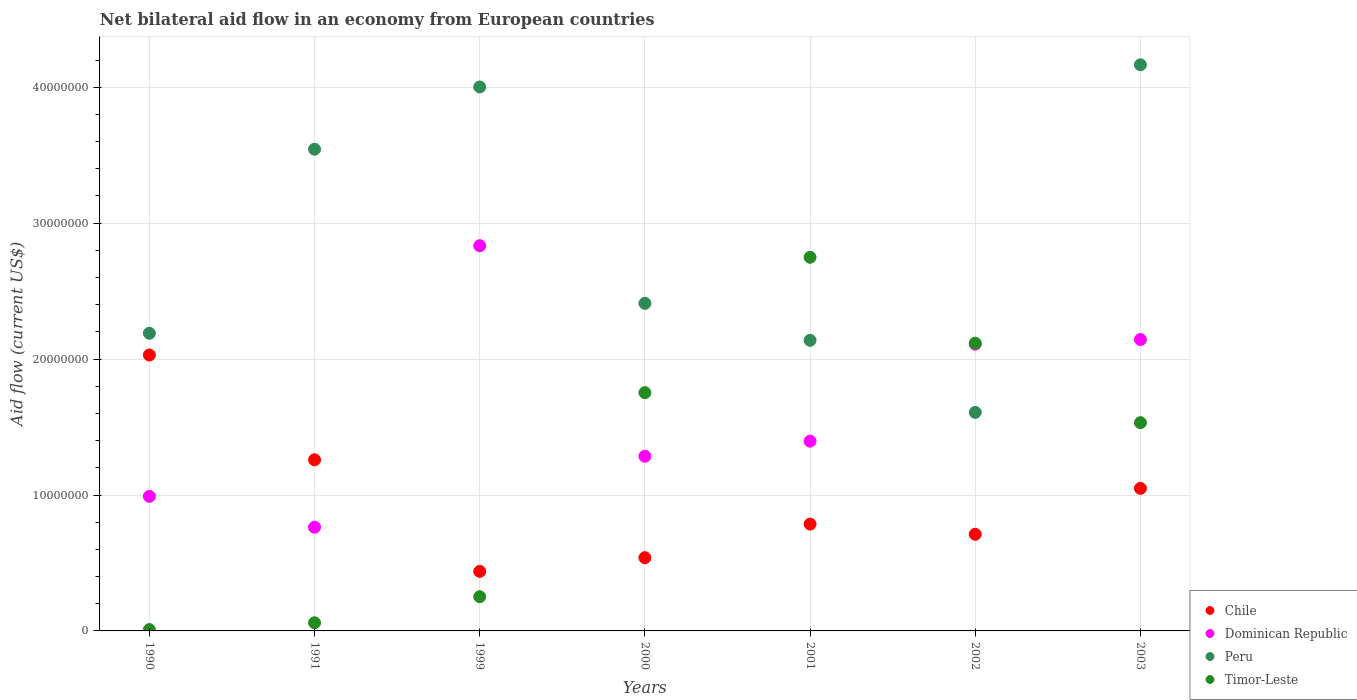Is the number of dotlines equal to the number of legend labels?
Offer a terse response. Yes. What is the net bilateral aid flow in Dominican Republic in 2003?
Offer a terse response. 2.14e+07. Across all years, what is the maximum net bilateral aid flow in Peru?
Provide a short and direct response. 4.16e+07. Across all years, what is the minimum net bilateral aid flow in Dominican Republic?
Give a very brief answer. 7.63e+06. In which year was the net bilateral aid flow in Dominican Republic maximum?
Offer a terse response. 1999. What is the total net bilateral aid flow in Peru in the graph?
Offer a terse response. 2.01e+08. What is the difference between the net bilateral aid flow in Chile in 2001 and that in 2003?
Keep it short and to the point. -2.63e+06. What is the difference between the net bilateral aid flow in Dominican Republic in 1991 and the net bilateral aid flow in Peru in 2000?
Provide a succinct answer. -1.65e+07. What is the average net bilateral aid flow in Chile per year?
Give a very brief answer. 9.73e+06. In the year 1999, what is the difference between the net bilateral aid flow in Dominican Republic and net bilateral aid flow in Chile?
Your answer should be very brief. 2.40e+07. What is the ratio of the net bilateral aid flow in Dominican Republic in 1991 to that in 2003?
Offer a terse response. 0.36. Is the net bilateral aid flow in Chile in 1999 less than that in 2000?
Your response must be concise. Yes. What is the difference between the highest and the second highest net bilateral aid flow in Timor-Leste?
Offer a terse response. 6.32e+06. What is the difference between the highest and the lowest net bilateral aid flow in Timor-Leste?
Offer a very short reply. 2.74e+07. In how many years, is the net bilateral aid flow in Chile greater than the average net bilateral aid flow in Chile taken over all years?
Make the answer very short. 3. Is it the case that in every year, the sum of the net bilateral aid flow in Peru and net bilateral aid flow in Chile  is greater than the sum of net bilateral aid flow in Timor-Leste and net bilateral aid flow in Dominican Republic?
Give a very brief answer. Yes. Is it the case that in every year, the sum of the net bilateral aid flow in Peru and net bilateral aid flow in Dominican Republic  is greater than the net bilateral aid flow in Timor-Leste?
Give a very brief answer. Yes. Does the net bilateral aid flow in Peru monotonically increase over the years?
Give a very brief answer. No. Does the graph contain any zero values?
Provide a short and direct response. No. Does the graph contain grids?
Your answer should be compact. Yes. How many legend labels are there?
Offer a terse response. 4. How are the legend labels stacked?
Your answer should be very brief. Vertical. What is the title of the graph?
Your answer should be very brief. Net bilateral aid flow in an economy from European countries. What is the Aid flow (current US$) in Chile in 1990?
Ensure brevity in your answer.  2.03e+07. What is the Aid flow (current US$) in Dominican Republic in 1990?
Make the answer very short. 9.90e+06. What is the Aid flow (current US$) in Peru in 1990?
Your response must be concise. 2.19e+07. What is the Aid flow (current US$) of Timor-Leste in 1990?
Ensure brevity in your answer.  1.00e+05. What is the Aid flow (current US$) of Chile in 1991?
Offer a very short reply. 1.26e+07. What is the Aid flow (current US$) in Dominican Republic in 1991?
Provide a short and direct response. 7.63e+06. What is the Aid flow (current US$) in Peru in 1991?
Your response must be concise. 3.54e+07. What is the Aid flow (current US$) in Chile in 1999?
Give a very brief answer. 4.38e+06. What is the Aid flow (current US$) of Dominican Republic in 1999?
Provide a succinct answer. 2.83e+07. What is the Aid flow (current US$) of Peru in 1999?
Your answer should be very brief. 4.00e+07. What is the Aid flow (current US$) in Timor-Leste in 1999?
Provide a succinct answer. 2.52e+06. What is the Aid flow (current US$) of Chile in 2000?
Offer a terse response. 5.39e+06. What is the Aid flow (current US$) in Dominican Republic in 2000?
Offer a terse response. 1.28e+07. What is the Aid flow (current US$) in Peru in 2000?
Offer a terse response. 2.41e+07. What is the Aid flow (current US$) in Timor-Leste in 2000?
Your answer should be very brief. 1.75e+07. What is the Aid flow (current US$) of Chile in 2001?
Make the answer very short. 7.86e+06. What is the Aid flow (current US$) in Dominican Republic in 2001?
Your response must be concise. 1.40e+07. What is the Aid flow (current US$) of Peru in 2001?
Your response must be concise. 2.14e+07. What is the Aid flow (current US$) in Timor-Leste in 2001?
Your response must be concise. 2.75e+07. What is the Aid flow (current US$) of Chile in 2002?
Give a very brief answer. 7.11e+06. What is the Aid flow (current US$) in Dominican Republic in 2002?
Provide a short and direct response. 2.11e+07. What is the Aid flow (current US$) in Peru in 2002?
Your answer should be very brief. 1.61e+07. What is the Aid flow (current US$) in Timor-Leste in 2002?
Provide a succinct answer. 2.12e+07. What is the Aid flow (current US$) of Chile in 2003?
Keep it short and to the point. 1.05e+07. What is the Aid flow (current US$) of Dominican Republic in 2003?
Provide a succinct answer. 2.14e+07. What is the Aid flow (current US$) of Peru in 2003?
Keep it short and to the point. 4.16e+07. What is the Aid flow (current US$) of Timor-Leste in 2003?
Provide a short and direct response. 1.53e+07. Across all years, what is the maximum Aid flow (current US$) in Chile?
Make the answer very short. 2.03e+07. Across all years, what is the maximum Aid flow (current US$) in Dominican Republic?
Make the answer very short. 2.83e+07. Across all years, what is the maximum Aid flow (current US$) of Peru?
Make the answer very short. 4.16e+07. Across all years, what is the maximum Aid flow (current US$) of Timor-Leste?
Keep it short and to the point. 2.75e+07. Across all years, what is the minimum Aid flow (current US$) in Chile?
Ensure brevity in your answer.  4.38e+06. Across all years, what is the minimum Aid flow (current US$) of Dominican Republic?
Provide a short and direct response. 7.63e+06. Across all years, what is the minimum Aid flow (current US$) of Peru?
Offer a terse response. 1.61e+07. What is the total Aid flow (current US$) of Chile in the graph?
Your response must be concise. 6.81e+07. What is the total Aid flow (current US$) of Dominican Republic in the graph?
Your response must be concise. 1.15e+08. What is the total Aid flow (current US$) of Peru in the graph?
Offer a very short reply. 2.01e+08. What is the total Aid flow (current US$) in Timor-Leste in the graph?
Keep it short and to the point. 8.47e+07. What is the difference between the Aid flow (current US$) of Chile in 1990 and that in 1991?
Make the answer very short. 7.71e+06. What is the difference between the Aid flow (current US$) in Dominican Republic in 1990 and that in 1991?
Give a very brief answer. 2.27e+06. What is the difference between the Aid flow (current US$) in Peru in 1990 and that in 1991?
Provide a succinct answer. -1.35e+07. What is the difference between the Aid flow (current US$) of Timor-Leste in 1990 and that in 1991?
Your response must be concise. -5.00e+05. What is the difference between the Aid flow (current US$) of Chile in 1990 and that in 1999?
Your answer should be compact. 1.59e+07. What is the difference between the Aid flow (current US$) in Dominican Republic in 1990 and that in 1999?
Ensure brevity in your answer.  -1.84e+07. What is the difference between the Aid flow (current US$) in Peru in 1990 and that in 1999?
Your response must be concise. -1.81e+07. What is the difference between the Aid flow (current US$) in Timor-Leste in 1990 and that in 1999?
Give a very brief answer. -2.42e+06. What is the difference between the Aid flow (current US$) of Chile in 1990 and that in 2000?
Give a very brief answer. 1.49e+07. What is the difference between the Aid flow (current US$) of Dominican Republic in 1990 and that in 2000?
Provide a succinct answer. -2.95e+06. What is the difference between the Aid flow (current US$) of Peru in 1990 and that in 2000?
Ensure brevity in your answer.  -2.20e+06. What is the difference between the Aid flow (current US$) in Timor-Leste in 1990 and that in 2000?
Your response must be concise. -1.74e+07. What is the difference between the Aid flow (current US$) of Chile in 1990 and that in 2001?
Make the answer very short. 1.24e+07. What is the difference between the Aid flow (current US$) in Dominican Republic in 1990 and that in 2001?
Provide a succinct answer. -4.06e+06. What is the difference between the Aid flow (current US$) of Peru in 1990 and that in 2001?
Your answer should be very brief. 5.20e+05. What is the difference between the Aid flow (current US$) in Timor-Leste in 1990 and that in 2001?
Make the answer very short. -2.74e+07. What is the difference between the Aid flow (current US$) in Chile in 1990 and that in 2002?
Provide a succinct answer. 1.32e+07. What is the difference between the Aid flow (current US$) in Dominican Republic in 1990 and that in 2002?
Ensure brevity in your answer.  -1.12e+07. What is the difference between the Aid flow (current US$) in Peru in 1990 and that in 2002?
Provide a succinct answer. 5.82e+06. What is the difference between the Aid flow (current US$) in Timor-Leste in 1990 and that in 2002?
Ensure brevity in your answer.  -2.11e+07. What is the difference between the Aid flow (current US$) in Chile in 1990 and that in 2003?
Ensure brevity in your answer.  9.81e+06. What is the difference between the Aid flow (current US$) in Dominican Republic in 1990 and that in 2003?
Provide a succinct answer. -1.15e+07. What is the difference between the Aid flow (current US$) of Peru in 1990 and that in 2003?
Your response must be concise. -1.98e+07. What is the difference between the Aid flow (current US$) of Timor-Leste in 1990 and that in 2003?
Ensure brevity in your answer.  -1.52e+07. What is the difference between the Aid flow (current US$) in Chile in 1991 and that in 1999?
Keep it short and to the point. 8.21e+06. What is the difference between the Aid flow (current US$) in Dominican Republic in 1991 and that in 1999?
Keep it short and to the point. -2.07e+07. What is the difference between the Aid flow (current US$) in Peru in 1991 and that in 1999?
Your response must be concise. -4.58e+06. What is the difference between the Aid flow (current US$) in Timor-Leste in 1991 and that in 1999?
Your answer should be very brief. -1.92e+06. What is the difference between the Aid flow (current US$) of Chile in 1991 and that in 2000?
Provide a succinct answer. 7.20e+06. What is the difference between the Aid flow (current US$) of Dominican Republic in 1991 and that in 2000?
Give a very brief answer. -5.22e+06. What is the difference between the Aid flow (current US$) of Peru in 1991 and that in 2000?
Offer a very short reply. 1.13e+07. What is the difference between the Aid flow (current US$) of Timor-Leste in 1991 and that in 2000?
Provide a succinct answer. -1.69e+07. What is the difference between the Aid flow (current US$) of Chile in 1991 and that in 2001?
Provide a short and direct response. 4.73e+06. What is the difference between the Aid flow (current US$) in Dominican Republic in 1991 and that in 2001?
Provide a short and direct response. -6.33e+06. What is the difference between the Aid flow (current US$) in Peru in 1991 and that in 2001?
Your response must be concise. 1.41e+07. What is the difference between the Aid flow (current US$) in Timor-Leste in 1991 and that in 2001?
Your answer should be very brief. -2.69e+07. What is the difference between the Aid flow (current US$) in Chile in 1991 and that in 2002?
Keep it short and to the point. 5.48e+06. What is the difference between the Aid flow (current US$) in Dominican Republic in 1991 and that in 2002?
Give a very brief answer. -1.35e+07. What is the difference between the Aid flow (current US$) of Peru in 1991 and that in 2002?
Ensure brevity in your answer.  1.94e+07. What is the difference between the Aid flow (current US$) of Timor-Leste in 1991 and that in 2002?
Your answer should be compact. -2.06e+07. What is the difference between the Aid flow (current US$) in Chile in 1991 and that in 2003?
Keep it short and to the point. 2.10e+06. What is the difference between the Aid flow (current US$) of Dominican Republic in 1991 and that in 2003?
Your response must be concise. -1.38e+07. What is the difference between the Aid flow (current US$) in Peru in 1991 and that in 2003?
Your answer should be very brief. -6.21e+06. What is the difference between the Aid flow (current US$) of Timor-Leste in 1991 and that in 2003?
Provide a succinct answer. -1.47e+07. What is the difference between the Aid flow (current US$) of Chile in 1999 and that in 2000?
Your response must be concise. -1.01e+06. What is the difference between the Aid flow (current US$) in Dominican Republic in 1999 and that in 2000?
Provide a succinct answer. 1.55e+07. What is the difference between the Aid flow (current US$) of Peru in 1999 and that in 2000?
Your answer should be compact. 1.59e+07. What is the difference between the Aid flow (current US$) in Timor-Leste in 1999 and that in 2000?
Give a very brief answer. -1.50e+07. What is the difference between the Aid flow (current US$) of Chile in 1999 and that in 2001?
Make the answer very short. -3.48e+06. What is the difference between the Aid flow (current US$) of Dominican Republic in 1999 and that in 2001?
Offer a very short reply. 1.44e+07. What is the difference between the Aid flow (current US$) of Peru in 1999 and that in 2001?
Your answer should be very brief. 1.86e+07. What is the difference between the Aid flow (current US$) in Timor-Leste in 1999 and that in 2001?
Give a very brief answer. -2.50e+07. What is the difference between the Aid flow (current US$) of Chile in 1999 and that in 2002?
Keep it short and to the point. -2.73e+06. What is the difference between the Aid flow (current US$) in Dominican Republic in 1999 and that in 2002?
Offer a terse response. 7.24e+06. What is the difference between the Aid flow (current US$) of Peru in 1999 and that in 2002?
Ensure brevity in your answer.  2.39e+07. What is the difference between the Aid flow (current US$) in Timor-Leste in 1999 and that in 2002?
Your answer should be compact. -1.86e+07. What is the difference between the Aid flow (current US$) of Chile in 1999 and that in 2003?
Provide a succinct answer. -6.11e+06. What is the difference between the Aid flow (current US$) in Dominican Republic in 1999 and that in 2003?
Ensure brevity in your answer.  6.90e+06. What is the difference between the Aid flow (current US$) in Peru in 1999 and that in 2003?
Provide a short and direct response. -1.63e+06. What is the difference between the Aid flow (current US$) in Timor-Leste in 1999 and that in 2003?
Your answer should be very brief. -1.28e+07. What is the difference between the Aid flow (current US$) in Chile in 2000 and that in 2001?
Make the answer very short. -2.47e+06. What is the difference between the Aid flow (current US$) of Dominican Republic in 2000 and that in 2001?
Keep it short and to the point. -1.11e+06. What is the difference between the Aid flow (current US$) of Peru in 2000 and that in 2001?
Provide a short and direct response. 2.72e+06. What is the difference between the Aid flow (current US$) of Timor-Leste in 2000 and that in 2001?
Your answer should be very brief. -9.96e+06. What is the difference between the Aid flow (current US$) in Chile in 2000 and that in 2002?
Offer a terse response. -1.72e+06. What is the difference between the Aid flow (current US$) of Dominican Republic in 2000 and that in 2002?
Give a very brief answer. -8.25e+06. What is the difference between the Aid flow (current US$) in Peru in 2000 and that in 2002?
Offer a terse response. 8.02e+06. What is the difference between the Aid flow (current US$) of Timor-Leste in 2000 and that in 2002?
Your response must be concise. -3.64e+06. What is the difference between the Aid flow (current US$) of Chile in 2000 and that in 2003?
Your answer should be very brief. -5.10e+06. What is the difference between the Aid flow (current US$) in Dominican Republic in 2000 and that in 2003?
Provide a short and direct response. -8.59e+06. What is the difference between the Aid flow (current US$) in Peru in 2000 and that in 2003?
Provide a succinct answer. -1.76e+07. What is the difference between the Aid flow (current US$) of Timor-Leste in 2000 and that in 2003?
Ensure brevity in your answer.  2.21e+06. What is the difference between the Aid flow (current US$) of Chile in 2001 and that in 2002?
Ensure brevity in your answer.  7.50e+05. What is the difference between the Aid flow (current US$) of Dominican Republic in 2001 and that in 2002?
Keep it short and to the point. -7.14e+06. What is the difference between the Aid flow (current US$) of Peru in 2001 and that in 2002?
Ensure brevity in your answer.  5.30e+06. What is the difference between the Aid flow (current US$) in Timor-Leste in 2001 and that in 2002?
Make the answer very short. 6.32e+06. What is the difference between the Aid flow (current US$) of Chile in 2001 and that in 2003?
Your answer should be very brief. -2.63e+06. What is the difference between the Aid flow (current US$) in Dominican Republic in 2001 and that in 2003?
Offer a terse response. -7.48e+06. What is the difference between the Aid flow (current US$) in Peru in 2001 and that in 2003?
Ensure brevity in your answer.  -2.03e+07. What is the difference between the Aid flow (current US$) in Timor-Leste in 2001 and that in 2003?
Provide a short and direct response. 1.22e+07. What is the difference between the Aid flow (current US$) in Chile in 2002 and that in 2003?
Offer a terse response. -3.38e+06. What is the difference between the Aid flow (current US$) in Dominican Republic in 2002 and that in 2003?
Provide a short and direct response. -3.40e+05. What is the difference between the Aid flow (current US$) of Peru in 2002 and that in 2003?
Your answer should be compact. -2.56e+07. What is the difference between the Aid flow (current US$) of Timor-Leste in 2002 and that in 2003?
Give a very brief answer. 5.85e+06. What is the difference between the Aid flow (current US$) of Chile in 1990 and the Aid flow (current US$) of Dominican Republic in 1991?
Keep it short and to the point. 1.27e+07. What is the difference between the Aid flow (current US$) of Chile in 1990 and the Aid flow (current US$) of Peru in 1991?
Offer a terse response. -1.51e+07. What is the difference between the Aid flow (current US$) of Chile in 1990 and the Aid flow (current US$) of Timor-Leste in 1991?
Keep it short and to the point. 1.97e+07. What is the difference between the Aid flow (current US$) in Dominican Republic in 1990 and the Aid flow (current US$) in Peru in 1991?
Provide a short and direct response. -2.55e+07. What is the difference between the Aid flow (current US$) of Dominican Republic in 1990 and the Aid flow (current US$) of Timor-Leste in 1991?
Your answer should be very brief. 9.30e+06. What is the difference between the Aid flow (current US$) in Peru in 1990 and the Aid flow (current US$) in Timor-Leste in 1991?
Provide a succinct answer. 2.13e+07. What is the difference between the Aid flow (current US$) in Chile in 1990 and the Aid flow (current US$) in Dominican Republic in 1999?
Offer a terse response. -8.04e+06. What is the difference between the Aid flow (current US$) in Chile in 1990 and the Aid flow (current US$) in Peru in 1999?
Provide a succinct answer. -1.97e+07. What is the difference between the Aid flow (current US$) of Chile in 1990 and the Aid flow (current US$) of Timor-Leste in 1999?
Your answer should be very brief. 1.78e+07. What is the difference between the Aid flow (current US$) in Dominican Republic in 1990 and the Aid flow (current US$) in Peru in 1999?
Offer a very short reply. -3.01e+07. What is the difference between the Aid flow (current US$) of Dominican Republic in 1990 and the Aid flow (current US$) of Timor-Leste in 1999?
Provide a succinct answer. 7.38e+06. What is the difference between the Aid flow (current US$) in Peru in 1990 and the Aid flow (current US$) in Timor-Leste in 1999?
Offer a very short reply. 1.94e+07. What is the difference between the Aid flow (current US$) in Chile in 1990 and the Aid flow (current US$) in Dominican Republic in 2000?
Give a very brief answer. 7.45e+06. What is the difference between the Aid flow (current US$) in Chile in 1990 and the Aid flow (current US$) in Peru in 2000?
Keep it short and to the point. -3.80e+06. What is the difference between the Aid flow (current US$) of Chile in 1990 and the Aid flow (current US$) of Timor-Leste in 2000?
Your answer should be very brief. 2.77e+06. What is the difference between the Aid flow (current US$) in Dominican Republic in 1990 and the Aid flow (current US$) in Peru in 2000?
Provide a short and direct response. -1.42e+07. What is the difference between the Aid flow (current US$) in Dominican Republic in 1990 and the Aid flow (current US$) in Timor-Leste in 2000?
Your answer should be very brief. -7.63e+06. What is the difference between the Aid flow (current US$) of Peru in 1990 and the Aid flow (current US$) of Timor-Leste in 2000?
Your answer should be compact. 4.37e+06. What is the difference between the Aid flow (current US$) of Chile in 1990 and the Aid flow (current US$) of Dominican Republic in 2001?
Make the answer very short. 6.34e+06. What is the difference between the Aid flow (current US$) in Chile in 1990 and the Aid flow (current US$) in Peru in 2001?
Offer a terse response. -1.08e+06. What is the difference between the Aid flow (current US$) of Chile in 1990 and the Aid flow (current US$) of Timor-Leste in 2001?
Your response must be concise. -7.19e+06. What is the difference between the Aid flow (current US$) of Dominican Republic in 1990 and the Aid flow (current US$) of Peru in 2001?
Give a very brief answer. -1.15e+07. What is the difference between the Aid flow (current US$) of Dominican Republic in 1990 and the Aid flow (current US$) of Timor-Leste in 2001?
Keep it short and to the point. -1.76e+07. What is the difference between the Aid flow (current US$) in Peru in 1990 and the Aid flow (current US$) in Timor-Leste in 2001?
Offer a very short reply. -5.59e+06. What is the difference between the Aid flow (current US$) of Chile in 1990 and the Aid flow (current US$) of Dominican Republic in 2002?
Your answer should be very brief. -8.00e+05. What is the difference between the Aid flow (current US$) of Chile in 1990 and the Aid flow (current US$) of Peru in 2002?
Make the answer very short. 4.22e+06. What is the difference between the Aid flow (current US$) of Chile in 1990 and the Aid flow (current US$) of Timor-Leste in 2002?
Offer a terse response. -8.70e+05. What is the difference between the Aid flow (current US$) of Dominican Republic in 1990 and the Aid flow (current US$) of Peru in 2002?
Give a very brief answer. -6.18e+06. What is the difference between the Aid flow (current US$) of Dominican Republic in 1990 and the Aid flow (current US$) of Timor-Leste in 2002?
Your answer should be very brief. -1.13e+07. What is the difference between the Aid flow (current US$) in Peru in 1990 and the Aid flow (current US$) in Timor-Leste in 2002?
Offer a very short reply. 7.30e+05. What is the difference between the Aid flow (current US$) in Chile in 1990 and the Aid flow (current US$) in Dominican Republic in 2003?
Provide a succinct answer. -1.14e+06. What is the difference between the Aid flow (current US$) in Chile in 1990 and the Aid flow (current US$) in Peru in 2003?
Provide a short and direct response. -2.14e+07. What is the difference between the Aid flow (current US$) of Chile in 1990 and the Aid flow (current US$) of Timor-Leste in 2003?
Offer a terse response. 4.98e+06. What is the difference between the Aid flow (current US$) in Dominican Republic in 1990 and the Aid flow (current US$) in Peru in 2003?
Your answer should be compact. -3.18e+07. What is the difference between the Aid flow (current US$) in Dominican Republic in 1990 and the Aid flow (current US$) in Timor-Leste in 2003?
Your answer should be very brief. -5.42e+06. What is the difference between the Aid flow (current US$) of Peru in 1990 and the Aid flow (current US$) of Timor-Leste in 2003?
Your answer should be compact. 6.58e+06. What is the difference between the Aid flow (current US$) in Chile in 1991 and the Aid flow (current US$) in Dominican Republic in 1999?
Keep it short and to the point. -1.58e+07. What is the difference between the Aid flow (current US$) in Chile in 1991 and the Aid flow (current US$) in Peru in 1999?
Your answer should be compact. -2.74e+07. What is the difference between the Aid flow (current US$) in Chile in 1991 and the Aid flow (current US$) in Timor-Leste in 1999?
Your answer should be compact. 1.01e+07. What is the difference between the Aid flow (current US$) in Dominican Republic in 1991 and the Aid flow (current US$) in Peru in 1999?
Offer a terse response. -3.24e+07. What is the difference between the Aid flow (current US$) in Dominican Republic in 1991 and the Aid flow (current US$) in Timor-Leste in 1999?
Ensure brevity in your answer.  5.11e+06. What is the difference between the Aid flow (current US$) in Peru in 1991 and the Aid flow (current US$) in Timor-Leste in 1999?
Provide a succinct answer. 3.29e+07. What is the difference between the Aid flow (current US$) of Chile in 1991 and the Aid flow (current US$) of Dominican Republic in 2000?
Provide a short and direct response. -2.60e+05. What is the difference between the Aid flow (current US$) of Chile in 1991 and the Aid flow (current US$) of Peru in 2000?
Your answer should be compact. -1.15e+07. What is the difference between the Aid flow (current US$) in Chile in 1991 and the Aid flow (current US$) in Timor-Leste in 2000?
Offer a terse response. -4.94e+06. What is the difference between the Aid flow (current US$) of Dominican Republic in 1991 and the Aid flow (current US$) of Peru in 2000?
Provide a succinct answer. -1.65e+07. What is the difference between the Aid flow (current US$) in Dominican Republic in 1991 and the Aid flow (current US$) in Timor-Leste in 2000?
Your answer should be compact. -9.90e+06. What is the difference between the Aid flow (current US$) in Peru in 1991 and the Aid flow (current US$) in Timor-Leste in 2000?
Your answer should be compact. 1.79e+07. What is the difference between the Aid flow (current US$) of Chile in 1991 and the Aid flow (current US$) of Dominican Republic in 2001?
Provide a short and direct response. -1.37e+06. What is the difference between the Aid flow (current US$) in Chile in 1991 and the Aid flow (current US$) in Peru in 2001?
Offer a very short reply. -8.79e+06. What is the difference between the Aid flow (current US$) of Chile in 1991 and the Aid flow (current US$) of Timor-Leste in 2001?
Your answer should be very brief. -1.49e+07. What is the difference between the Aid flow (current US$) in Dominican Republic in 1991 and the Aid flow (current US$) in Peru in 2001?
Give a very brief answer. -1.38e+07. What is the difference between the Aid flow (current US$) in Dominican Republic in 1991 and the Aid flow (current US$) in Timor-Leste in 2001?
Offer a terse response. -1.99e+07. What is the difference between the Aid flow (current US$) in Peru in 1991 and the Aid flow (current US$) in Timor-Leste in 2001?
Make the answer very short. 7.95e+06. What is the difference between the Aid flow (current US$) of Chile in 1991 and the Aid flow (current US$) of Dominican Republic in 2002?
Provide a short and direct response. -8.51e+06. What is the difference between the Aid flow (current US$) in Chile in 1991 and the Aid flow (current US$) in Peru in 2002?
Ensure brevity in your answer.  -3.49e+06. What is the difference between the Aid flow (current US$) of Chile in 1991 and the Aid flow (current US$) of Timor-Leste in 2002?
Provide a short and direct response. -8.58e+06. What is the difference between the Aid flow (current US$) of Dominican Republic in 1991 and the Aid flow (current US$) of Peru in 2002?
Your response must be concise. -8.45e+06. What is the difference between the Aid flow (current US$) of Dominican Republic in 1991 and the Aid flow (current US$) of Timor-Leste in 2002?
Offer a terse response. -1.35e+07. What is the difference between the Aid flow (current US$) in Peru in 1991 and the Aid flow (current US$) in Timor-Leste in 2002?
Provide a succinct answer. 1.43e+07. What is the difference between the Aid flow (current US$) in Chile in 1991 and the Aid flow (current US$) in Dominican Republic in 2003?
Provide a succinct answer. -8.85e+06. What is the difference between the Aid flow (current US$) of Chile in 1991 and the Aid flow (current US$) of Peru in 2003?
Offer a terse response. -2.91e+07. What is the difference between the Aid flow (current US$) of Chile in 1991 and the Aid flow (current US$) of Timor-Leste in 2003?
Keep it short and to the point. -2.73e+06. What is the difference between the Aid flow (current US$) in Dominican Republic in 1991 and the Aid flow (current US$) in Peru in 2003?
Offer a very short reply. -3.40e+07. What is the difference between the Aid flow (current US$) in Dominican Republic in 1991 and the Aid flow (current US$) in Timor-Leste in 2003?
Keep it short and to the point. -7.69e+06. What is the difference between the Aid flow (current US$) of Peru in 1991 and the Aid flow (current US$) of Timor-Leste in 2003?
Ensure brevity in your answer.  2.01e+07. What is the difference between the Aid flow (current US$) in Chile in 1999 and the Aid flow (current US$) in Dominican Republic in 2000?
Give a very brief answer. -8.47e+06. What is the difference between the Aid flow (current US$) of Chile in 1999 and the Aid flow (current US$) of Peru in 2000?
Your answer should be very brief. -1.97e+07. What is the difference between the Aid flow (current US$) of Chile in 1999 and the Aid flow (current US$) of Timor-Leste in 2000?
Make the answer very short. -1.32e+07. What is the difference between the Aid flow (current US$) of Dominican Republic in 1999 and the Aid flow (current US$) of Peru in 2000?
Give a very brief answer. 4.24e+06. What is the difference between the Aid flow (current US$) of Dominican Republic in 1999 and the Aid flow (current US$) of Timor-Leste in 2000?
Your response must be concise. 1.08e+07. What is the difference between the Aid flow (current US$) in Peru in 1999 and the Aid flow (current US$) in Timor-Leste in 2000?
Give a very brief answer. 2.25e+07. What is the difference between the Aid flow (current US$) of Chile in 1999 and the Aid flow (current US$) of Dominican Republic in 2001?
Offer a terse response. -9.58e+06. What is the difference between the Aid flow (current US$) of Chile in 1999 and the Aid flow (current US$) of Peru in 2001?
Provide a short and direct response. -1.70e+07. What is the difference between the Aid flow (current US$) of Chile in 1999 and the Aid flow (current US$) of Timor-Leste in 2001?
Offer a terse response. -2.31e+07. What is the difference between the Aid flow (current US$) in Dominican Republic in 1999 and the Aid flow (current US$) in Peru in 2001?
Ensure brevity in your answer.  6.96e+06. What is the difference between the Aid flow (current US$) in Dominican Republic in 1999 and the Aid flow (current US$) in Timor-Leste in 2001?
Offer a very short reply. 8.50e+05. What is the difference between the Aid flow (current US$) of Peru in 1999 and the Aid flow (current US$) of Timor-Leste in 2001?
Your answer should be compact. 1.25e+07. What is the difference between the Aid flow (current US$) in Chile in 1999 and the Aid flow (current US$) in Dominican Republic in 2002?
Ensure brevity in your answer.  -1.67e+07. What is the difference between the Aid flow (current US$) of Chile in 1999 and the Aid flow (current US$) of Peru in 2002?
Your answer should be very brief. -1.17e+07. What is the difference between the Aid flow (current US$) of Chile in 1999 and the Aid flow (current US$) of Timor-Leste in 2002?
Keep it short and to the point. -1.68e+07. What is the difference between the Aid flow (current US$) of Dominican Republic in 1999 and the Aid flow (current US$) of Peru in 2002?
Offer a very short reply. 1.23e+07. What is the difference between the Aid flow (current US$) in Dominican Republic in 1999 and the Aid flow (current US$) in Timor-Leste in 2002?
Give a very brief answer. 7.17e+06. What is the difference between the Aid flow (current US$) in Peru in 1999 and the Aid flow (current US$) in Timor-Leste in 2002?
Give a very brief answer. 1.88e+07. What is the difference between the Aid flow (current US$) of Chile in 1999 and the Aid flow (current US$) of Dominican Republic in 2003?
Your answer should be very brief. -1.71e+07. What is the difference between the Aid flow (current US$) of Chile in 1999 and the Aid flow (current US$) of Peru in 2003?
Provide a short and direct response. -3.73e+07. What is the difference between the Aid flow (current US$) of Chile in 1999 and the Aid flow (current US$) of Timor-Leste in 2003?
Your response must be concise. -1.09e+07. What is the difference between the Aid flow (current US$) of Dominican Republic in 1999 and the Aid flow (current US$) of Peru in 2003?
Provide a short and direct response. -1.33e+07. What is the difference between the Aid flow (current US$) in Dominican Republic in 1999 and the Aid flow (current US$) in Timor-Leste in 2003?
Make the answer very short. 1.30e+07. What is the difference between the Aid flow (current US$) in Peru in 1999 and the Aid flow (current US$) in Timor-Leste in 2003?
Give a very brief answer. 2.47e+07. What is the difference between the Aid flow (current US$) in Chile in 2000 and the Aid flow (current US$) in Dominican Republic in 2001?
Give a very brief answer. -8.57e+06. What is the difference between the Aid flow (current US$) of Chile in 2000 and the Aid flow (current US$) of Peru in 2001?
Offer a terse response. -1.60e+07. What is the difference between the Aid flow (current US$) of Chile in 2000 and the Aid flow (current US$) of Timor-Leste in 2001?
Ensure brevity in your answer.  -2.21e+07. What is the difference between the Aid flow (current US$) of Dominican Republic in 2000 and the Aid flow (current US$) of Peru in 2001?
Make the answer very short. -8.53e+06. What is the difference between the Aid flow (current US$) in Dominican Republic in 2000 and the Aid flow (current US$) in Timor-Leste in 2001?
Offer a terse response. -1.46e+07. What is the difference between the Aid flow (current US$) of Peru in 2000 and the Aid flow (current US$) of Timor-Leste in 2001?
Provide a succinct answer. -3.39e+06. What is the difference between the Aid flow (current US$) of Chile in 2000 and the Aid flow (current US$) of Dominican Republic in 2002?
Keep it short and to the point. -1.57e+07. What is the difference between the Aid flow (current US$) in Chile in 2000 and the Aid flow (current US$) in Peru in 2002?
Make the answer very short. -1.07e+07. What is the difference between the Aid flow (current US$) in Chile in 2000 and the Aid flow (current US$) in Timor-Leste in 2002?
Offer a very short reply. -1.58e+07. What is the difference between the Aid flow (current US$) in Dominican Republic in 2000 and the Aid flow (current US$) in Peru in 2002?
Make the answer very short. -3.23e+06. What is the difference between the Aid flow (current US$) of Dominican Republic in 2000 and the Aid flow (current US$) of Timor-Leste in 2002?
Provide a short and direct response. -8.32e+06. What is the difference between the Aid flow (current US$) in Peru in 2000 and the Aid flow (current US$) in Timor-Leste in 2002?
Give a very brief answer. 2.93e+06. What is the difference between the Aid flow (current US$) of Chile in 2000 and the Aid flow (current US$) of Dominican Republic in 2003?
Your response must be concise. -1.60e+07. What is the difference between the Aid flow (current US$) in Chile in 2000 and the Aid flow (current US$) in Peru in 2003?
Offer a very short reply. -3.63e+07. What is the difference between the Aid flow (current US$) in Chile in 2000 and the Aid flow (current US$) in Timor-Leste in 2003?
Give a very brief answer. -9.93e+06. What is the difference between the Aid flow (current US$) in Dominican Republic in 2000 and the Aid flow (current US$) in Peru in 2003?
Your answer should be compact. -2.88e+07. What is the difference between the Aid flow (current US$) in Dominican Republic in 2000 and the Aid flow (current US$) in Timor-Leste in 2003?
Your answer should be compact. -2.47e+06. What is the difference between the Aid flow (current US$) of Peru in 2000 and the Aid flow (current US$) of Timor-Leste in 2003?
Provide a short and direct response. 8.78e+06. What is the difference between the Aid flow (current US$) of Chile in 2001 and the Aid flow (current US$) of Dominican Republic in 2002?
Offer a terse response. -1.32e+07. What is the difference between the Aid flow (current US$) of Chile in 2001 and the Aid flow (current US$) of Peru in 2002?
Make the answer very short. -8.22e+06. What is the difference between the Aid flow (current US$) of Chile in 2001 and the Aid flow (current US$) of Timor-Leste in 2002?
Your answer should be very brief. -1.33e+07. What is the difference between the Aid flow (current US$) in Dominican Republic in 2001 and the Aid flow (current US$) in Peru in 2002?
Your answer should be very brief. -2.12e+06. What is the difference between the Aid flow (current US$) of Dominican Republic in 2001 and the Aid flow (current US$) of Timor-Leste in 2002?
Provide a succinct answer. -7.21e+06. What is the difference between the Aid flow (current US$) in Peru in 2001 and the Aid flow (current US$) in Timor-Leste in 2002?
Your response must be concise. 2.10e+05. What is the difference between the Aid flow (current US$) of Chile in 2001 and the Aid flow (current US$) of Dominican Republic in 2003?
Make the answer very short. -1.36e+07. What is the difference between the Aid flow (current US$) of Chile in 2001 and the Aid flow (current US$) of Peru in 2003?
Your answer should be compact. -3.38e+07. What is the difference between the Aid flow (current US$) in Chile in 2001 and the Aid flow (current US$) in Timor-Leste in 2003?
Your answer should be very brief. -7.46e+06. What is the difference between the Aid flow (current US$) of Dominican Republic in 2001 and the Aid flow (current US$) of Peru in 2003?
Keep it short and to the point. -2.77e+07. What is the difference between the Aid flow (current US$) in Dominican Republic in 2001 and the Aid flow (current US$) in Timor-Leste in 2003?
Your response must be concise. -1.36e+06. What is the difference between the Aid flow (current US$) in Peru in 2001 and the Aid flow (current US$) in Timor-Leste in 2003?
Your response must be concise. 6.06e+06. What is the difference between the Aid flow (current US$) of Chile in 2002 and the Aid flow (current US$) of Dominican Republic in 2003?
Your response must be concise. -1.43e+07. What is the difference between the Aid flow (current US$) in Chile in 2002 and the Aid flow (current US$) in Peru in 2003?
Keep it short and to the point. -3.45e+07. What is the difference between the Aid flow (current US$) in Chile in 2002 and the Aid flow (current US$) in Timor-Leste in 2003?
Give a very brief answer. -8.21e+06. What is the difference between the Aid flow (current US$) in Dominican Republic in 2002 and the Aid flow (current US$) in Peru in 2003?
Your answer should be very brief. -2.06e+07. What is the difference between the Aid flow (current US$) of Dominican Republic in 2002 and the Aid flow (current US$) of Timor-Leste in 2003?
Offer a terse response. 5.78e+06. What is the difference between the Aid flow (current US$) in Peru in 2002 and the Aid flow (current US$) in Timor-Leste in 2003?
Your response must be concise. 7.60e+05. What is the average Aid flow (current US$) in Chile per year?
Your answer should be very brief. 9.73e+06. What is the average Aid flow (current US$) of Dominican Republic per year?
Offer a very short reply. 1.65e+07. What is the average Aid flow (current US$) in Peru per year?
Offer a terse response. 2.87e+07. What is the average Aid flow (current US$) of Timor-Leste per year?
Keep it short and to the point. 1.21e+07. In the year 1990, what is the difference between the Aid flow (current US$) of Chile and Aid flow (current US$) of Dominican Republic?
Make the answer very short. 1.04e+07. In the year 1990, what is the difference between the Aid flow (current US$) of Chile and Aid flow (current US$) of Peru?
Provide a short and direct response. -1.60e+06. In the year 1990, what is the difference between the Aid flow (current US$) in Chile and Aid flow (current US$) in Timor-Leste?
Offer a very short reply. 2.02e+07. In the year 1990, what is the difference between the Aid flow (current US$) in Dominican Republic and Aid flow (current US$) in Peru?
Make the answer very short. -1.20e+07. In the year 1990, what is the difference between the Aid flow (current US$) of Dominican Republic and Aid flow (current US$) of Timor-Leste?
Your response must be concise. 9.80e+06. In the year 1990, what is the difference between the Aid flow (current US$) in Peru and Aid flow (current US$) in Timor-Leste?
Offer a very short reply. 2.18e+07. In the year 1991, what is the difference between the Aid flow (current US$) in Chile and Aid flow (current US$) in Dominican Republic?
Keep it short and to the point. 4.96e+06. In the year 1991, what is the difference between the Aid flow (current US$) in Chile and Aid flow (current US$) in Peru?
Offer a very short reply. -2.28e+07. In the year 1991, what is the difference between the Aid flow (current US$) in Chile and Aid flow (current US$) in Timor-Leste?
Make the answer very short. 1.20e+07. In the year 1991, what is the difference between the Aid flow (current US$) of Dominican Republic and Aid flow (current US$) of Peru?
Your response must be concise. -2.78e+07. In the year 1991, what is the difference between the Aid flow (current US$) in Dominican Republic and Aid flow (current US$) in Timor-Leste?
Ensure brevity in your answer.  7.03e+06. In the year 1991, what is the difference between the Aid flow (current US$) of Peru and Aid flow (current US$) of Timor-Leste?
Your answer should be compact. 3.48e+07. In the year 1999, what is the difference between the Aid flow (current US$) of Chile and Aid flow (current US$) of Dominican Republic?
Provide a succinct answer. -2.40e+07. In the year 1999, what is the difference between the Aid flow (current US$) of Chile and Aid flow (current US$) of Peru?
Offer a terse response. -3.56e+07. In the year 1999, what is the difference between the Aid flow (current US$) of Chile and Aid flow (current US$) of Timor-Leste?
Provide a succinct answer. 1.86e+06. In the year 1999, what is the difference between the Aid flow (current US$) in Dominican Republic and Aid flow (current US$) in Peru?
Your response must be concise. -1.17e+07. In the year 1999, what is the difference between the Aid flow (current US$) in Dominican Republic and Aid flow (current US$) in Timor-Leste?
Ensure brevity in your answer.  2.58e+07. In the year 1999, what is the difference between the Aid flow (current US$) of Peru and Aid flow (current US$) of Timor-Leste?
Make the answer very short. 3.75e+07. In the year 2000, what is the difference between the Aid flow (current US$) in Chile and Aid flow (current US$) in Dominican Republic?
Provide a short and direct response. -7.46e+06. In the year 2000, what is the difference between the Aid flow (current US$) in Chile and Aid flow (current US$) in Peru?
Your answer should be very brief. -1.87e+07. In the year 2000, what is the difference between the Aid flow (current US$) in Chile and Aid flow (current US$) in Timor-Leste?
Provide a succinct answer. -1.21e+07. In the year 2000, what is the difference between the Aid flow (current US$) in Dominican Republic and Aid flow (current US$) in Peru?
Your answer should be very brief. -1.12e+07. In the year 2000, what is the difference between the Aid flow (current US$) in Dominican Republic and Aid flow (current US$) in Timor-Leste?
Make the answer very short. -4.68e+06. In the year 2000, what is the difference between the Aid flow (current US$) of Peru and Aid flow (current US$) of Timor-Leste?
Keep it short and to the point. 6.57e+06. In the year 2001, what is the difference between the Aid flow (current US$) in Chile and Aid flow (current US$) in Dominican Republic?
Your response must be concise. -6.10e+06. In the year 2001, what is the difference between the Aid flow (current US$) in Chile and Aid flow (current US$) in Peru?
Your response must be concise. -1.35e+07. In the year 2001, what is the difference between the Aid flow (current US$) in Chile and Aid flow (current US$) in Timor-Leste?
Provide a succinct answer. -1.96e+07. In the year 2001, what is the difference between the Aid flow (current US$) in Dominican Republic and Aid flow (current US$) in Peru?
Make the answer very short. -7.42e+06. In the year 2001, what is the difference between the Aid flow (current US$) of Dominican Republic and Aid flow (current US$) of Timor-Leste?
Give a very brief answer. -1.35e+07. In the year 2001, what is the difference between the Aid flow (current US$) in Peru and Aid flow (current US$) in Timor-Leste?
Your answer should be compact. -6.11e+06. In the year 2002, what is the difference between the Aid flow (current US$) in Chile and Aid flow (current US$) in Dominican Republic?
Keep it short and to the point. -1.40e+07. In the year 2002, what is the difference between the Aid flow (current US$) in Chile and Aid flow (current US$) in Peru?
Offer a very short reply. -8.97e+06. In the year 2002, what is the difference between the Aid flow (current US$) of Chile and Aid flow (current US$) of Timor-Leste?
Your answer should be very brief. -1.41e+07. In the year 2002, what is the difference between the Aid flow (current US$) in Dominican Republic and Aid flow (current US$) in Peru?
Make the answer very short. 5.02e+06. In the year 2002, what is the difference between the Aid flow (current US$) of Dominican Republic and Aid flow (current US$) of Timor-Leste?
Provide a short and direct response. -7.00e+04. In the year 2002, what is the difference between the Aid flow (current US$) in Peru and Aid flow (current US$) in Timor-Leste?
Ensure brevity in your answer.  -5.09e+06. In the year 2003, what is the difference between the Aid flow (current US$) in Chile and Aid flow (current US$) in Dominican Republic?
Ensure brevity in your answer.  -1.10e+07. In the year 2003, what is the difference between the Aid flow (current US$) of Chile and Aid flow (current US$) of Peru?
Offer a very short reply. -3.12e+07. In the year 2003, what is the difference between the Aid flow (current US$) in Chile and Aid flow (current US$) in Timor-Leste?
Make the answer very short. -4.83e+06. In the year 2003, what is the difference between the Aid flow (current US$) in Dominican Republic and Aid flow (current US$) in Peru?
Keep it short and to the point. -2.02e+07. In the year 2003, what is the difference between the Aid flow (current US$) in Dominican Republic and Aid flow (current US$) in Timor-Leste?
Your response must be concise. 6.12e+06. In the year 2003, what is the difference between the Aid flow (current US$) of Peru and Aid flow (current US$) of Timor-Leste?
Your answer should be very brief. 2.63e+07. What is the ratio of the Aid flow (current US$) of Chile in 1990 to that in 1991?
Provide a succinct answer. 1.61. What is the ratio of the Aid flow (current US$) of Dominican Republic in 1990 to that in 1991?
Your answer should be compact. 1.3. What is the ratio of the Aid flow (current US$) of Peru in 1990 to that in 1991?
Keep it short and to the point. 0.62. What is the ratio of the Aid flow (current US$) of Timor-Leste in 1990 to that in 1991?
Offer a very short reply. 0.17. What is the ratio of the Aid flow (current US$) of Chile in 1990 to that in 1999?
Your response must be concise. 4.63. What is the ratio of the Aid flow (current US$) of Dominican Republic in 1990 to that in 1999?
Ensure brevity in your answer.  0.35. What is the ratio of the Aid flow (current US$) in Peru in 1990 to that in 1999?
Keep it short and to the point. 0.55. What is the ratio of the Aid flow (current US$) in Timor-Leste in 1990 to that in 1999?
Offer a terse response. 0.04. What is the ratio of the Aid flow (current US$) in Chile in 1990 to that in 2000?
Make the answer very short. 3.77. What is the ratio of the Aid flow (current US$) of Dominican Republic in 1990 to that in 2000?
Your answer should be very brief. 0.77. What is the ratio of the Aid flow (current US$) of Peru in 1990 to that in 2000?
Make the answer very short. 0.91. What is the ratio of the Aid flow (current US$) of Timor-Leste in 1990 to that in 2000?
Ensure brevity in your answer.  0.01. What is the ratio of the Aid flow (current US$) of Chile in 1990 to that in 2001?
Provide a succinct answer. 2.58. What is the ratio of the Aid flow (current US$) in Dominican Republic in 1990 to that in 2001?
Provide a short and direct response. 0.71. What is the ratio of the Aid flow (current US$) in Peru in 1990 to that in 2001?
Ensure brevity in your answer.  1.02. What is the ratio of the Aid flow (current US$) of Timor-Leste in 1990 to that in 2001?
Offer a terse response. 0. What is the ratio of the Aid flow (current US$) in Chile in 1990 to that in 2002?
Your answer should be compact. 2.86. What is the ratio of the Aid flow (current US$) in Dominican Republic in 1990 to that in 2002?
Keep it short and to the point. 0.47. What is the ratio of the Aid flow (current US$) of Peru in 1990 to that in 2002?
Give a very brief answer. 1.36. What is the ratio of the Aid flow (current US$) of Timor-Leste in 1990 to that in 2002?
Make the answer very short. 0. What is the ratio of the Aid flow (current US$) of Chile in 1990 to that in 2003?
Your response must be concise. 1.94. What is the ratio of the Aid flow (current US$) of Dominican Republic in 1990 to that in 2003?
Provide a short and direct response. 0.46. What is the ratio of the Aid flow (current US$) of Peru in 1990 to that in 2003?
Offer a very short reply. 0.53. What is the ratio of the Aid flow (current US$) in Timor-Leste in 1990 to that in 2003?
Give a very brief answer. 0.01. What is the ratio of the Aid flow (current US$) of Chile in 1991 to that in 1999?
Provide a succinct answer. 2.87. What is the ratio of the Aid flow (current US$) in Dominican Republic in 1991 to that in 1999?
Ensure brevity in your answer.  0.27. What is the ratio of the Aid flow (current US$) of Peru in 1991 to that in 1999?
Ensure brevity in your answer.  0.89. What is the ratio of the Aid flow (current US$) of Timor-Leste in 1991 to that in 1999?
Your answer should be very brief. 0.24. What is the ratio of the Aid flow (current US$) of Chile in 1991 to that in 2000?
Offer a terse response. 2.34. What is the ratio of the Aid flow (current US$) in Dominican Republic in 1991 to that in 2000?
Your answer should be compact. 0.59. What is the ratio of the Aid flow (current US$) in Peru in 1991 to that in 2000?
Make the answer very short. 1.47. What is the ratio of the Aid flow (current US$) of Timor-Leste in 1991 to that in 2000?
Provide a succinct answer. 0.03. What is the ratio of the Aid flow (current US$) of Chile in 1991 to that in 2001?
Ensure brevity in your answer.  1.6. What is the ratio of the Aid flow (current US$) in Dominican Republic in 1991 to that in 2001?
Offer a terse response. 0.55. What is the ratio of the Aid flow (current US$) in Peru in 1991 to that in 2001?
Ensure brevity in your answer.  1.66. What is the ratio of the Aid flow (current US$) of Timor-Leste in 1991 to that in 2001?
Your response must be concise. 0.02. What is the ratio of the Aid flow (current US$) in Chile in 1991 to that in 2002?
Your response must be concise. 1.77. What is the ratio of the Aid flow (current US$) of Dominican Republic in 1991 to that in 2002?
Give a very brief answer. 0.36. What is the ratio of the Aid flow (current US$) in Peru in 1991 to that in 2002?
Make the answer very short. 2.2. What is the ratio of the Aid flow (current US$) of Timor-Leste in 1991 to that in 2002?
Your response must be concise. 0.03. What is the ratio of the Aid flow (current US$) in Chile in 1991 to that in 2003?
Offer a terse response. 1.2. What is the ratio of the Aid flow (current US$) in Dominican Republic in 1991 to that in 2003?
Provide a succinct answer. 0.36. What is the ratio of the Aid flow (current US$) in Peru in 1991 to that in 2003?
Your response must be concise. 0.85. What is the ratio of the Aid flow (current US$) of Timor-Leste in 1991 to that in 2003?
Your answer should be compact. 0.04. What is the ratio of the Aid flow (current US$) in Chile in 1999 to that in 2000?
Keep it short and to the point. 0.81. What is the ratio of the Aid flow (current US$) in Dominican Republic in 1999 to that in 2000?
Your response must be concise. 2.21. What is the ratio of the Aid flow (current US$) in Peru in 1999 to that in 2000?
Make the answer very short. 1.66. What is the ratio of the Aid flow (current US$) of Timor-Leste in 1999 to that in 2000?
Offer a terse response. 0.14. What is the ratio of the Aid flow (current US$) of Chile in 1999 to that in 2001?
Your answer should be compact. 0.56. What is the ratio of the Aid flow (current US$) in Dominican Republic in 1999 to that in 2001?
Your response must be concise. 2.03. What is the ratio of the Aid flow (current US$) in Peru in 1999 to that in 2001?
Offer a terse response. 1.87. What is the ratio of the Aid flow (current US$) in Timor-Leste in 1999 to that in 2001?
Keep it short and to the point. 0.09. What is the ratio of the Aid flow (current US$) of Chile in 1999 to that in 2002?
Offer a very short reply. 0.62. What is the ratio of the Aid flow (current US$) of Dominican Republic in 1999 to that in 2002?
Make the answer very short. 1.34. What is the ratio of the Aid flow (current US$) of Peru in 1999 to that in 2002?
Your answer should be compact. 2.49. What is the ratio of the Aid flow (current US$) in Timor-Leste in 1999 to that in 2002?
Provide a short and direct response. 0.12. What is the ratio of the Aid flow (current US$) in Chile in 1999 to that in 2003?
Give a very brief answer. 0.42. What is the ratio of the Aid flow (current US$) in Dominican Republic in 1999 to that in 2003?
Offer a very short reply. 1.32. What is the ratio of the Aid flow (current US$) of Peru in 1999 to that in 2003?
Provide a succinct answer. 0.96. What is the ratio of the Aid flow (current US$) in Timor-Leste in 1999 to that in 2003?
Provide a short and direct response. 0.16. What is the ratio of the Aid flow (current US$) in Chile in 2000 to that in 2001?
Give a very brief answer. 0.69. What is the ratio of the Aid flow (current US$) of Dominican Republic in 2000 to that in 2001?
Your response must be concise. 0.92. What is the ratio of the Aid flow (current US$) of Peru in 2000 to that in 2001?
Offer a terse response. 1.13. What is the ratio of the Aid flow (current US$) in Timor-Leste in 2000 to that in 2001?
Provide a short and direct response. 0.64. What is the ratio of the Aid flow (current US$) in Chile in 2000 to that in 2002?
Your answer should be very brief. 0.76. What is the ratio of the Aid flow (current US$) of Dominican Republic in 2000 to that in 2002?
Your answer should be compact. 0.61. What is the ratio of the Aid flow (current US$) of Peru in 2000 to that in 2002?
Your answer should be very brief. 1.5. What is the ratio of the Aid flow (current US$) of Timor-Leste in 2000 to that in 2002?
Make the answer very short. 0.83. What is the ratio of the Aid flow (current US$) of Chile in 2000 to that in 2003?
Offer a very short reply. 0.51. What is the ratio of the Aid flow (current US$) in Dominican Republic in 2000 to that in 2003?
Offer a terse response. 0.6. What is the ratio of the Aid flow (current US$) of Peru in 2000 to that in 2003?
Your answer should be very brief. 0.58. What is the ratio of the Aid flow (current US$) of Timor-Leste in 2000 to that in 2003?
Your response must be concise. 1.14. What is the ratio of the Aid flow (current US$) in Chile in 2001 to that in 2002?
Your answer should be very brief. 1.11. What is the ratio of the Aid flow (current US$) of Dominican Republic in 2001 to that in 2002?
Keep it short and to the point. 0.66. What is the ratio of the Aid flow (current US$) of Peru in 2001 to that in 2002?
Offer a terse response. 1.33. What is the ratio of the Aid flow (current US$) in Timor-Leste in 2001 to that in 2002?
Ensure brevity in your answer.  1.3. What is the ratio of the Aid flow (current US$) of Chile in 2001 to that in 2003?
Your answer should be compact. 0.75. What is the ratio of the Aid flow (current US$) in Dominican Republic in 2001 to that in 2003?
Offer a very short reply. 0.65. What is the ratio of the Aid flow (current US$) of Peru in 2001 to that in 2003?
Your answer should be compact. 0.51. What is the ratio of the Aid flow (current US$) of Timor-Leste in 2001 to that in 2003?
Offer a very short reply. 1.79. What is the ratio of the Aid flow (current US$) of Chile in 2002 to that in 2003?
Keep it short and to the point. 0.68. What is the ratio of the Aid flow (current US$) in Dominican Republic in 2002 to that in 2003?
Provide a succinct answer. 0.98. What is the ratio of the Aid flow (current US$) in Peru in 2002 to that in 2003?
Make the answer very short. 0.39. What is the ratio of the Aid flow (current US$) of Timor-Leste in 2002 to that in 2003?
Keep it short and to the point. 1.38. What is the difference between the highest and the second highest Aid flow (current US$) of Chile?
Your response must be concise. 7.71e+06. What is the difference between the highest and the second highest Aid flow (current US$) of Dominican Republic?
Keep it short and to the point. 6.90e+06. What is the difference between the highest and the second highest Aid flow (current US$) of Peru?
Make the answer very short. 1.63e+06. What is the difference between the highest and the second highest Aid flow (current US$) of Timor-Leste?
Ensure brevity in your answer.  6.32e+06. What is the difference between the highest and the lowest Aid flow (current US$) of Chile?
Your answer should be compact. 1.59e+07. What is the difference between the highest and the lowest Aid flow (current US$) in Dominican Republic?
Give a very brief answer. 2.07e+07. What is the difference between the highest and the lowest Aid flow (current US$) in Peru?
Your answer should be compact. 2.56e+07. What is the difference between the highest and the lowest Aid flow (current US$) of Timor-Leste?
Provide a short and direct response. 2.74e+07. 